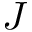<formula> <loc_0><loc_0><loc_500><loc_500>J</formula> 